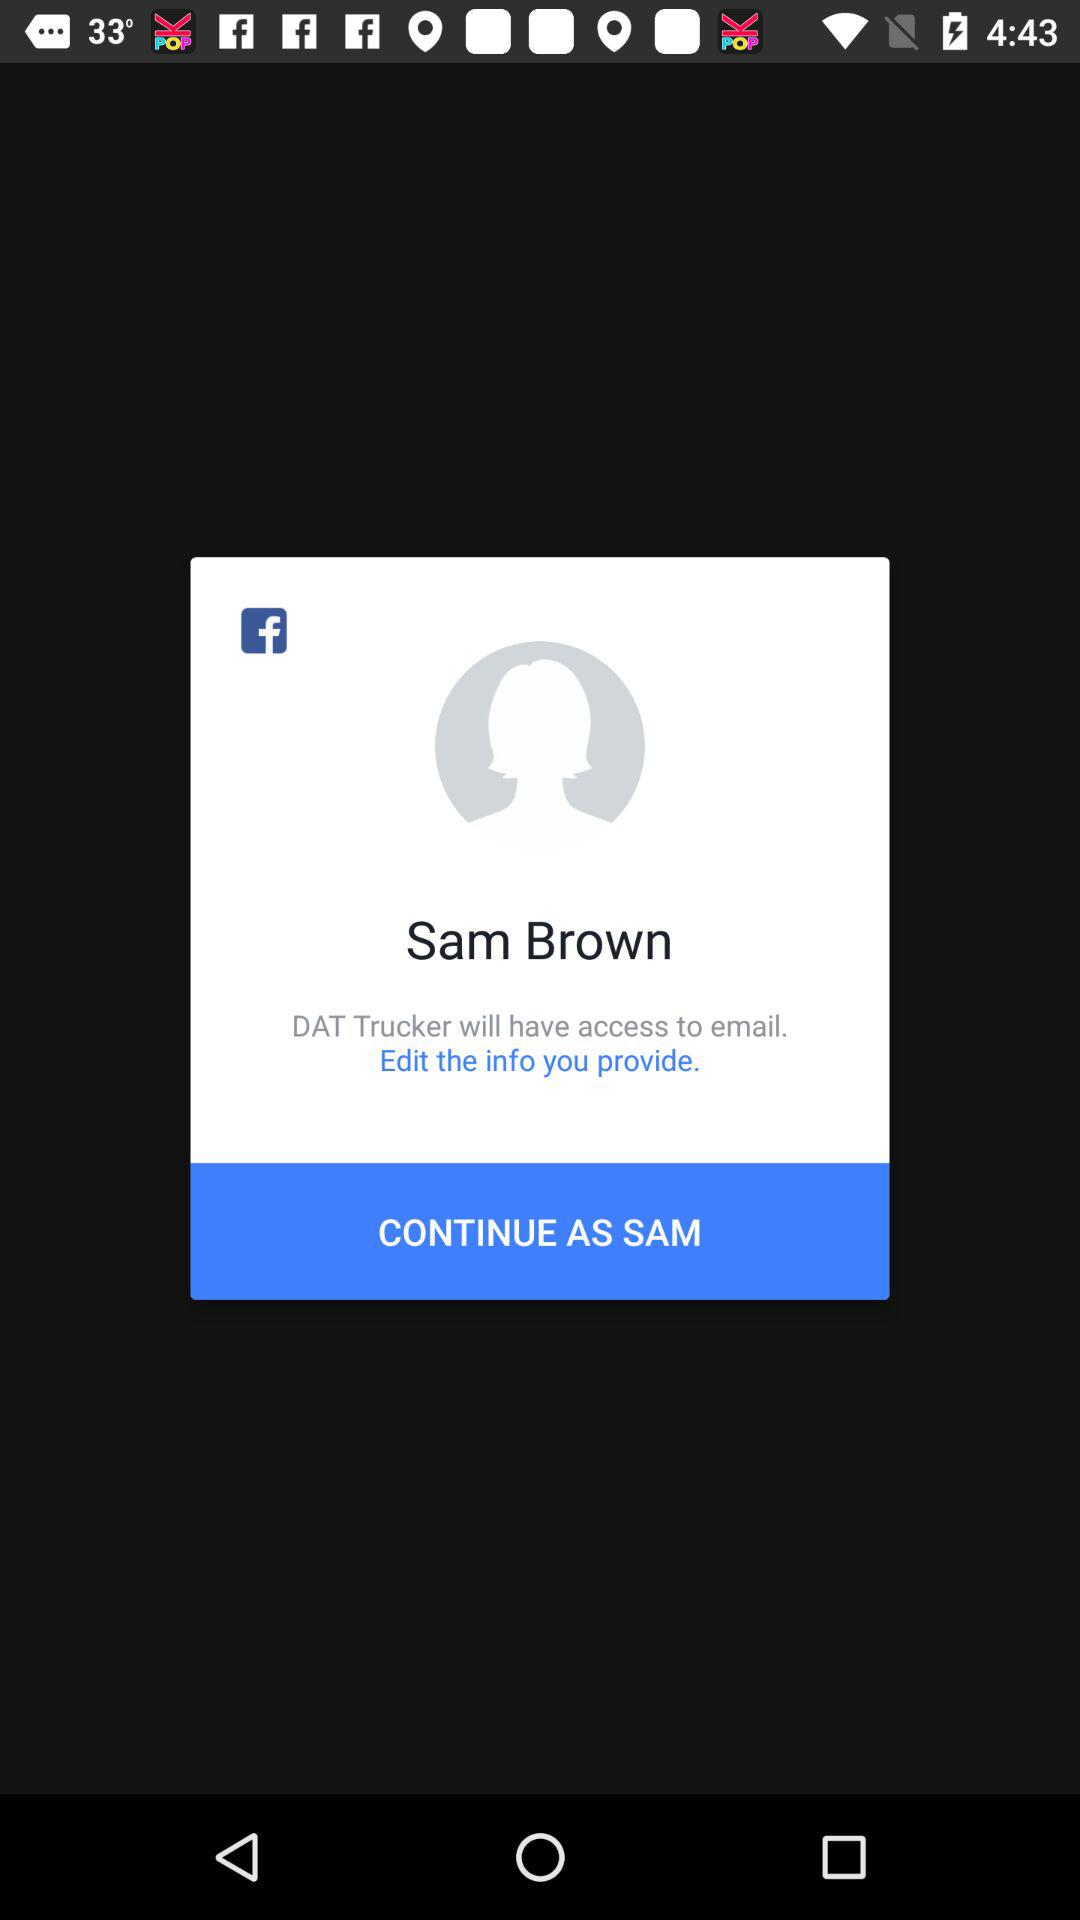What is the name of the user? The name of the user is Sam Brown. 